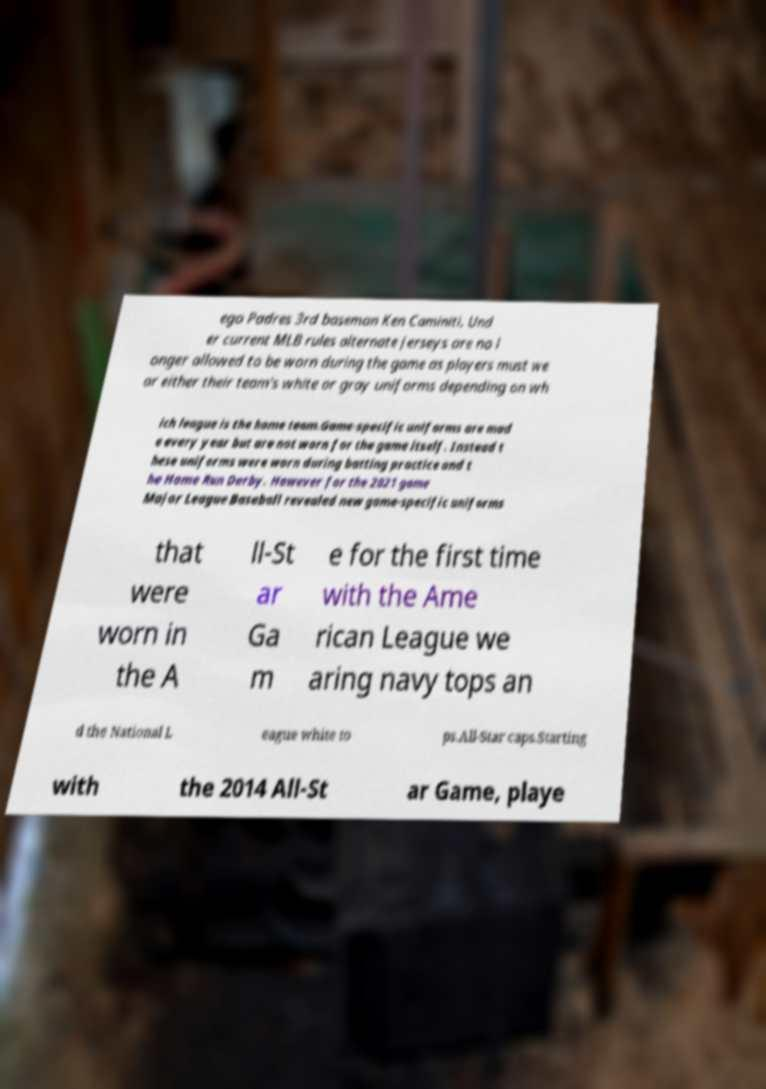Could you assist in decoding the text presented in this image and type it out clearly? ego Padres 3rd baseman Ken Caminiti. Und er current MLB rules alternate jerseys are no l onger allowed to be worn during the game as players must we ar either their team's white or gray uniforms depending on wh ich league is the home team.Game-specific uniforms are mad e every year but are not worn for the game itself. Instead t hese uniforms were worn during batting practice and t he Home Run Derby. However for the 2021 game Major League Baseball revealed new game-specific uniforms that were worn in the A ll-St ar Ga m e for the first time with the Ame rican League we aring navy tops an d the National L eague white to ps.All-Star caps.Starting with the 2014 All-St ar Game, playe 